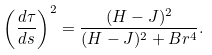<formula> <loc_0><loc_0><loc_500><loc_500>\left ( \frac { d \tau } { d s } \right ) ^ { 2 } = \frac { ( H - J ) ^ { 2 } } { ( H - J ) ^ { 2 } + B r ^ { 4 } } .</formula> 